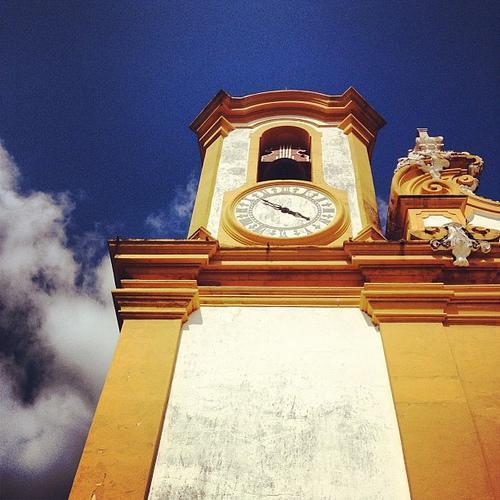How many clocks are in photo?
Give a very brief answer. 1. 